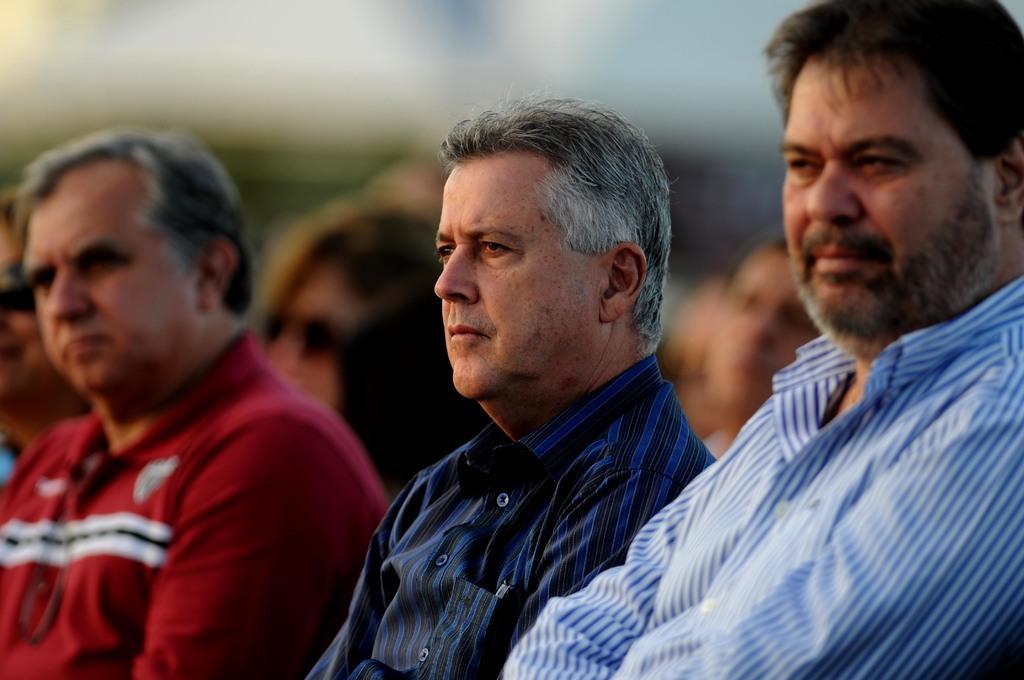Please provide a concise description of this image. In this image there are some persons standing on the bottom of this image as we can see the person on the left is wearing red color t shirt and there are two persons are at right side to this person, and there are some more persons in the background. 